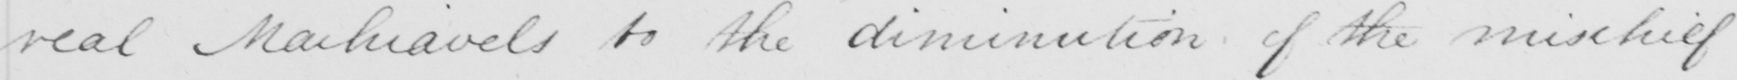What text is written in this handwritten line? real Machiavels to the diminution of the mischief 